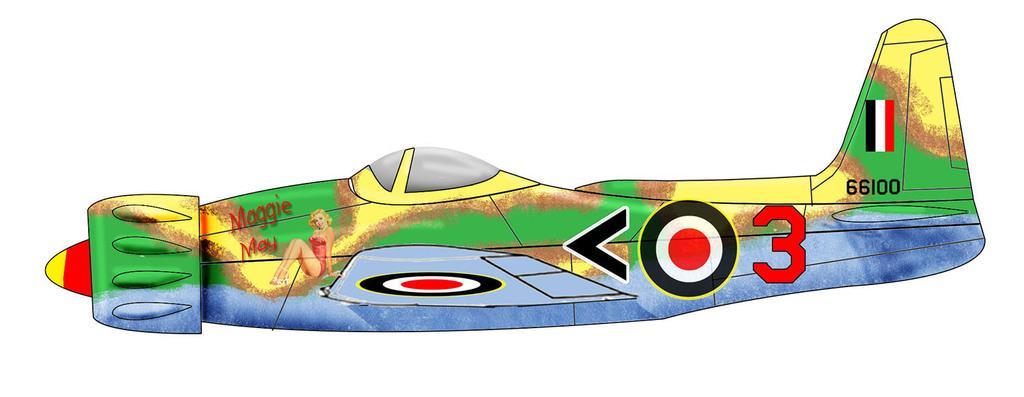How would you summarize this image in a sentence or two? It is an animated image of an airplane,there are some paintings done on the airplane. 